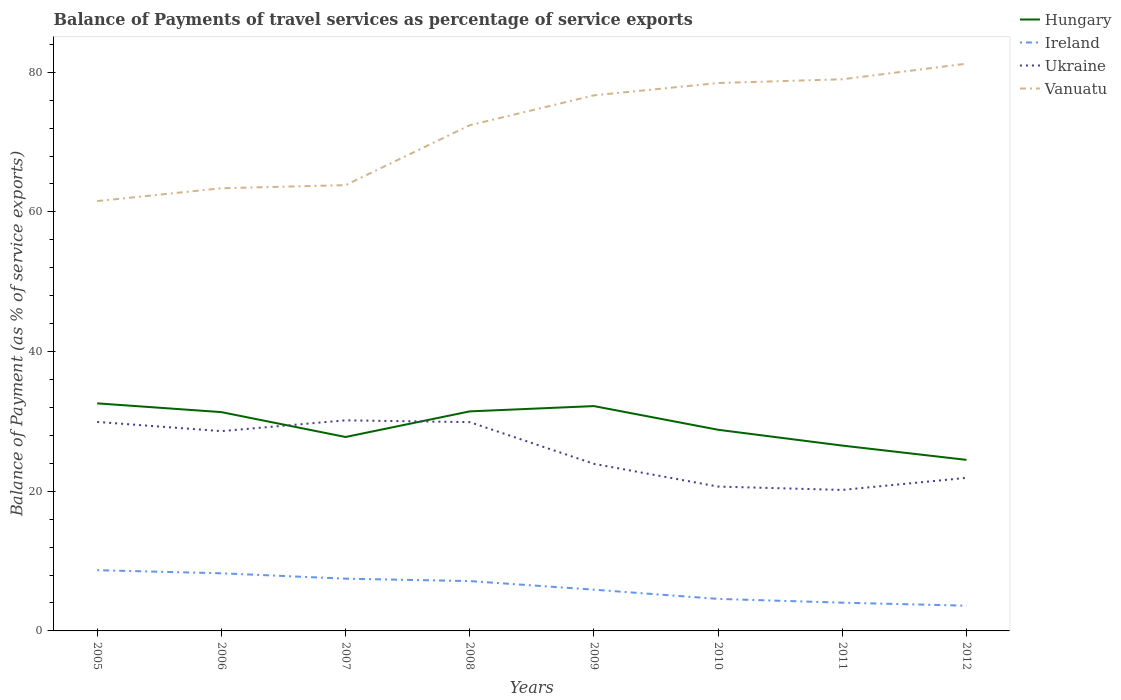Does the line corresponding to Vanuatu intersect with the line corresponding to Ireland?
Provide a short and direct response. No. Is the number of lines equal to the number of legend labels?
Your answer should be compact. Yes. Across all years, what is the maximum balance of payments of travel services in Ireland?
Offer a terse response. 3.61. What is the total balance of payments of travel services in Ukraine in the graph?
Give a very brief answer. 6. What is the difference between the highest and the second highest balance of payments of travel services in Ukraine?
Offer a very short reply. 9.97. What is the difference between the highest and the lowest balance of payments of travel services in Hungary?
Provide a succinct answer. 4. Are the values on the major ticks of Y-axis written in scientific E-notation?
Your answer should be very brief. No. Does the graph contain any zero values?
Ensure brevity in your answer.  No. Does the graph contain grids?
Give a very brief answer. No. How many legend labels are there?
Your response must be concise. 4. What is the title of the graph?
Provide a succinct answer. Balance of Payments of travel services as percentage of service exports. What is the label or title of the X-axis?
Your answer should be very brief. Years. What is the label or title of the Y-axis?
Make the answer very short. Balance of Payment (as % of service exports). What is the Balance of Payment (as % of service exports) of Hungary in 2005?
Ensure brevity in your answer.  32.59. What is the Balance of Payment (as % of service exports) in Ireland in 2005?
Offer a terse response. 8.7. What is the Balance of Payment (as % of service exports) in Ukraine in 2005?
Provide a succinct answer. 29.93. What is the Balance of Payment (as % of service exports) in Vanuatu in 2005?
Keep it short and to the point. 61.55. What is the Balance of Payment (as % of service exports) of Hungary in 2006?
Make the answer very short. 31.33. What is the Balance of Payment (as % of service exports) of Ireland in 2006?
Keep it short and to the point. 8.25. What is the Balance of Payment (as % of service exports) of Ukraine in 2006?
Provide a short and direct response. 28.61. What is the Balance of Payment (as % of service exports) of Vanuatu in 2006?
Your answer should be compact. 63.39. What is the Balance of Payment (as % of service exports) in Hungary in 2007?
Give a very brief answer. 27.77. What is the Balance of Payment (as % of service exports) in Ireland in 2007?
Provide a short and direct response. 7.48. What is the Balance of Payment (as % of service exports) in Ukraine in 2007?
Your response must be concise. 30.16. What is the Balance of Payment (as % of service exports) of Vanuatu in 2007?
Your answer should be very brief. 63.84. What is the Balance of Payment (as % of service exports) of Hungary in 2008?
Offer a terse response. 31.44. What is the Balance of Payment (as % of service exports) of Ireland in 2008?
Your answer should be very brief. 7.14. What is the Balance of Payment (as % of service exports) in Ukraine in 2008?
Provide a short and direct response. 29.9. What is the Balance of Payment (as % of service exports) in Vanuatu in 2008?
Give a very brief answer. 72.41. What is the Balance of Payment (as % of service exports) of Hungary in 2009?
Your answer should be very brief. 32.2. What is the Balance of Payment (as % of service exports) in Ireland in 2009?
Provide a succinct answer. 5.91. What is the Balance of Payment (as % of service exports) in Ukraine in 2009?
Provide a succinct answer. 23.93. What is the Balance of Payment (as % of service exports) in Vanuatu in 2009?
Ensure brevity in your answer.  76.69. What is the Balance of Payment (as % of service exports) of Hungary in 2010?
Your answer should be compact. 28.8. What is the Balance of Payment (as % of service exports) of Ireland in 2010?
Keep it short and to the point. 4.59. What is the Balance of Payment (as % of service exports) of Ukraine in 2010?
Keep it short and to the point. 20.67. What is the Balance of Payment (as % of service exports) in Vanuatu in 2010?
Provide a succinct answer. 78.46. What is the Balance of Payment (as % of service exports) in Hungary in 2011?
Offer a terse response. 26.54. What is the Balance of Payment (as % of service exports) of Ireland in 2011?
Ensure brevity in your answer.  4.04. What is the Balance of Payment (as % of service exports) of Ukraine in 2011?
Keep it short and to the point. 20.19. What is the Balance of Payment (as % of service exports) in Vanuatu in 2011?
Your response must be concise. 78.99. What is the Balance of Payment (as % of service exports) of Hungary in 2012?
Your answer should be compact. 24.5. What is the Balance of Payment (as % of service exports) of Ireland in 2012?
Keep it short and to the point. 3.61. What is the Balance of Payment (as % of service exports) in Ukraine in 2012?
Keep it short and to the point. 21.92. What is the Balance of Payment (as % of service exports) of Vanuatu in 2012?
Your answer should be very brief. 81.23. Across all years, what is the maximum Balance of Payment (as % of service exports) in Hungary?
Provide a short and direct response. 32.59. Across all years, what is the maximum Balance of Payment (as % of service exports) of Ireland?
Keep it short and to the point. 8.7. Across all years, what is the maximum Balance of Payment (as % of service exports) in Ukraine?
Make the answer very short. 30.16. Across all years, what is the maximum Balance of Payment (as % of service exports) of Vanuatu?
Provide a short and direct response. 81.23. Across all years, what is the minimum Balance of Payment (as % of service exports) in Hungary?
Provide a succinct answer. 24.5. Across all years, what is the minimum Balance of Payment (as % of service exports) of Ireland?
Provide a succinct answer. 3.61. Across all years, what is the minimum Balance of Payment (as % of service exports) of Ukraine?
Your answer should be very brief. 20.19. Across all years, what is the minimum Balance of Payment (as % of service exports) of Vanuatu?
Your answer should be compact. 61.55. What is the total Balance of Payment (as % of service exports) in Hungary in the graph?
Your answer should be compact. 235.16. What is the total Balance of Payment (as % of service exports) in Ireland in the graph?
Make the answer very short. 49.72. What is the total Balance of Payment (as % of service exports) in Ukraine in the graph?
Your answer should be very brief. 205.3. What is the total Balance of Payment (as % of service exports) of Vanuatu in the graph?
Your response must be concise. 576.56. What is the difference between the Balance of Payment (as % of service exports) of Hungary in 2005 and that in 2006?
Your answer should be very brief. 1.25. What is the difference between the Balance of Payment (as % of service exports) in Ireland in 2005 and that in 2006?
Offer a terse response. 0.45. What is the difference between the Balance of Payment (as % of service exports) of Ukraine in 2005 and that in 2006?
Your response must be concise. 1.32. What is the difference between the Balance of Payment (as % of service exports) in Vanuatu in 2005 and that in 2006?
Provide a succinct answer. -1.84. What is the difference between the Balance of Payment (as % of service exports) in Hungary in 2005 and that in 2007?
Your answer should be compact. 4.82. What is the difference between the Balance of Payment (as % of service exports) in Ireland in 2005 and that in 2007?
Your answer should be very brief. 1.22. What is the difference between the Balance of Payment (as % of service exports) in Ukraine in 2005 and that in 2007?
Offer a terse response. -0.23. What is the difference between the Balance of Payment (as % of service exports) in Vanuatu in 2005 and that in 2007?
Offer a terse response. -2.28. What is the difference between the Balance of Payment (as % of service exports) of Hungary in 2005 and that in 2008?
Your answer should be very brief. 1.15. What is the difference between the Balance of Payment (as % of service exports) of Ireland in 2005 and that in 2008?
Make the answer very short. 1.56. What is the difference between the Balance of Payment (as % of service exports) of Ukraine in 2005 and that in 2008?
Your response must be concise. 0.03. What is the difference between the Balance of Payment (as % of service exports) in Vanuatu in 2005 and that in 2008?
Make the answer very short. -10.86. What is the difference between the Balance of Payment (as % of service exports) in Hungary in 2005 and that in 2009?
Your response must be concise. 0.39. What is the difference between the Balance of Payment (as % of service exports) of Ireland in 2005 and that in 2009?
Make the answer very short. 2.79. What is the difference between the Balance of Payment (as % of service exports) of Ukraine in 2005 and that in 2009?
Your response must be concise. 6. What is the difference between the Balance of Payment (as % of service exports) of Vanuatu in 2005 and that in 2009?
Make the answer very short. -15.14. What is the difference between the Balance of Payment (as % of service exports) of Hungary in 2005 and that in 2010?
Offer a very short reply. 3.78. What is the difference between the Balance of Payment (as % of service exports) in Ireland in 2005 and that in 2010?
Provide a succinct answer. 4.11. What is the difference between the Balance of Payment (as % of service exports) of Ukraine in 2005 and that in 2010?
Your answer should be compact. 9.26. What is the difference between the Balance of Payment (as % of service exports) in Vanuatu in 2005 and that in 2010?
Provide a short and direct response. -16.9. What is the difference between the Balance of Payment (as % of service exports) in Hungary in 2005 and that in 2011?
Give a very brief answer. 6.05. What is the difference between the Balance of Payment (as % of service exports) in Ireland in 2005 and that in 2011?
Ensure brevity in your answer.  4.65. What is the difference between the Balance of Payment (as % of service exports) of Ukraine in 2005 and that in 2011?
Give a very brief answer. 9.74. What is the difference between the Balance of Payment (as % of service exports) of Vanuatu in 2005 and that in 2011?
Ensure brevity in your answer.  -17.44. What is the difference between the Balance of Payment (as % of service exports) of Hungary in 2005 and that in 2012?
Offer a very short reply. 8.09. What is the difference between the Balance of Payment (as % of service exports) of Ireland in 2005 and that in 2012?
Your answer should be compact. 5.09. What is the difference between the Balance of Payment (as % of service exports) in Ukraine in 2005 and that in 2012?
Offer a terse response. 8.01. What is the difference between the Balance of Payment (as % of service exports) of Vanuatu in 2005 and that in 2012?
Offer a terse response. -19.67. What is the difference between the Balance of Payment (as % of service exports) of Hungary in 2006 and that in 2007?
Give a very brief answer. 3.56. What is the difference between the Balance of Payment (as % of service exports) of Ireland in 2006 and that in 2007?
Provide a succinct answer. 0.77. What is the difference between the Balance of Payment (as % of service exports) in Ukraine in 2006 and that in 2007?
Keep it short and to the point. -1.55. What is the difference between the Balance of Payment (as % of service exports) of Vanuatu in 2006 and that in 2007?
Provide a short and direct response. -0.44. What is the difference between the Balance of Payment (as % of service exports) of Hungary in 2006 and that in 2008?
Keep it short and to the point. -0.1. What is the difference between the Balance of Payment (as % of service exports) in Ireland in 2006 and that in 2008?
Offer a terse response. 1.11. What is the difference between the Balance of Payment (as % of service exports) of Ukraine in 2006 and that in 2008?
Provide a short and direct response. -1.29. What is the difference between the Balance of Payment (as % of service exports) in Vanuatu in 2006 and that in 2008?
Your answer should be very brief. -9.02. What is the difference between the Balance of Payment (as % of service exports) of Hungary in 2006 and that in 2009?
Provide a short and direct response. -0.86. What is the difference between the Balance of Payment (as % of service exports) of Ireland in 2006 and that in 2009?
Offer a terse response. 2.34. What is the difference between the Balance of Payment (as % of service exports) of Ukraine in 2006 and that in 2009?
Offer a very short reply. 4.68. What is the difference between the Balance of Payment (as % of service exports) in Vanuatu in 2006 and that in 2009?
Your answer should be compact. -13.3. What is the difference between the Balance of Payment (as % of service exports) in Hungary in 2006 and that in 2010?
Make the answer very short. 2.53. What is the difference between the Balance of Payment (as % of service exports) of Ireland in 2006 and that in 2010?
Give a very brief answer. 3.67. What is the difference between the Balance of Payment (as % of service exports) in Ukraine in 2006 and that in 2010?
Give a very brief answer. 7.94. What is the difference between the Balance of Payment (as % of service exports) in Vanuatu in 2006 and that in 2010?
Your answer should be compact. -15.07. What is the difference between the Balance of Payment (as % of service exports) in Hungary in 2006 and that in 2011?
Provide a short and direct response. 4.79. What is the difference between the Balance of Payment (as % of service exports) of Ireland in 2006 and that in 2011?
Your answer should be compact. 4.21. What is the difference between the Balance of Payment (as % of service exports) of Ukraine in 2006 and that in 2011?
Offer a terse response. 8.42. What is the difference between the Balance of Payment (as % of service exports) in Vanuatu in 2006 and that in 2011?
Offer a terse response. -15.6. What is the difference between the Balance of Payment (as % of service exports) in Hungary in 2006 and that in 2012?
Provide a succinct answer. 6.84. What is the difference between the Balance of Payment (as % of service exports) in Ireland in 2006 and that in 2012?
Make the answer very short. 4.64. What is the difference between the Balance of Payment (as % of service exports) in Ukraine in 2006 and that in 2012?
Your answer should be very brief. 6.69. What is the difference between the Balance of Payment (as % of service exports) of Vanuatu in 2006 and that in 2012?
Ensure brevity in your answer.  -17.84. What is the difference between the Balance of Payment (as % of service exports) in Hungary in 2007 and that in 2008?
Offer a very short reply. -3.67. What is the difference between the Balance of Payment (as % of service exports) of Ireland in 2007 and that in 2008?
Offer a terse response. 0.35. What is the difference between the Balance of Payment (as % of service exports) in Ukraine in 2007 and that in 2008?
Make the answer very short. 0.26. What is the difference between the Balance of Payment (as % of service exports) of Vanuatu in 2007 and that in 2008?
Provide a short and direct response. -8.58. What is the difference between the Balance of Payment (as % of service exports) of Hungary in 2007 and that in 2009?
Keep it short and to the point. -4.43. What is the difference between the Balance of Payment (as % of service exports) in Ireland in 2007 and that in 2009?
Offer a terse response. 1.57. What is the difference between the Balance of Payment (as % of service exports) of Ukraine in 2007 and that in 2009?
Your response must be concise. 6.23. What is the difference between the Balance of Payment (as % of service exports) of Vanuatu in 2007 and that in 2009?
Ensure brevity in your answer.  -12.86. What is the difference between the Balance of Payment (as % of service exports) of Hungary in 2007 and that in 2010?
Offer a very short reply. -1.03. What is the difference between the Balance of Payment (as % of service exports) in Ireland in 2007 and that in 2010?
Provide a succinct answer. 2.9. What is the difference between the Balance of Payment (as % of service exports) in Ukraine in 2007 and that in 2010?
Offer a very short reply. 9.49. What is the difference between the Balance of Payment (as % of service exports) in Vanuatu in 2007 and that in 2010?
Keep it short and to the point. -14.62. What is the difference between the Balance of Payment (as % of service exports) of Hungary in 2007 and that in 2011?
Offer a very short reply. 1.23. What is the difference between the Balance of Payment (as % of service exports) in Ireland in 2007 and that in 2011?
Provide a succinct answer. 3.44. What is the difference between the Balance of Payment (as % of service exports) of Ukraine in 2007 and that in 2011?
Provide a short and direct response. 9.97. What is the difference between the Balance of Payment (as % of service exports) in Vanuatu in 2007 and that in 2011?
Your answer should be very brief. -15.16. What is the difference between the Balance of Payment (as % of service exports) in Hungary in 2007 and that in 2012?
Make the answer very short. 3.27. What is the difference between the Balance of Payment (as % of service exports) of Ireland in 2007 and that in 2012?
Provide a short and direct response. 3.87. What is the difference between the Balance of Payment (as % of service exports) in Ukraine in 2007 and that in 2012?
Keep it short and to the point. 8.24. What is the difference between the Balance of Payment (as % of service exports) in Vanuatu in 2007 and that in 2012?
Provide a short and direct response. -17.39. What is the difference between the Balance of Payment (as % of service exports) in Hungary in 2008 and that in 2009?
Offer a very short reply. -0.76. What is the difference between the Balance of Payment (as % of service exports) of Ireland in 2008 and that in 2009?
Provide a short and direct response. 1.23. What is the difference between the Balance of Payment (as % of service exports) of Ukraine in 2008 and that in 2009?
Ensure brevity in your answer.  5.97. What is the difference between the Balance of Payment (as % of service exports) in Vanuatu in 2008 and that in 2009?
Provide a succinct answer. -4.28. What is the difference between the Balance of Payment (as % of service exports) in Hungary in 2008 and that in 2010?
Your answer should be compact. 2.63. What is the difference between the Balance of Payment (as % of service exports) of Ireland in 2008 and that in 2010?
Provide a succinct answer. 2.55. What is the difference between the Balance of Payment (as % of service exports) of Ukraine in 2008 and that in 2010?
Your response must be concise. 9.23. What is the difference between the Balance of Payment (as % of service exports) in Vanuatu in 2008 and that in 2010?
Provide a short and direct response. -6.04. What is the difference between the Balance of Payment (as % of service exports) in Hungary in 2008 and that in 2011?
Your response must be concise. 4.9. What is the difference between the Balance of Payment (as % of service exports) in Ireland in 2008 and that in 2011?
Provide a short and direct response. 3.09. What is the difference between the Balance of Payment (as % of service exports) in Ukraine in 2008 and that in 2011?
Offer a very short reply. 9.71. What is the difference between the Balance of Payment (as % of service exports) of Vanuatu in 2008 and that in 2011?
Provide a succinct answer. -6.58. What is the difference between the Balance of Payment (as % of service exports) in Hungary in 2008 and that in 2012?
Offer a very short reply. 6.94. What is the difference between the Balance of Payment (as % of service exports) of Ireland in 2008 and that in 2012?
Offer a very short reply. 3.52. What is the difference between the Balance of Payment (as % of service exports) of Ukraine in 2008 and that in 2012?
Provide a short and direct response. 7.98. What is the difference between the Balance of Payment (as % of service exports) in Vanuatu in 2008 and that in 2012?
Give a very brief answer. -8.82. What is the difference between the Balance of Payment (as % of service exports) in Hungary in 2009 and that in 2010?
Give a very brief answer. 3.39. What is the difference between the Balance of Payment (as % of service exports) of Ireland in 2009 and that in 2010?
Provide a succinct answer. 1.32. What is the difference between the Balance of Payment (as % of service exports) in Ukraine in 2009 and that in 2010?
Your answer should be very brief. 3.26. What is the difference between the Balance of Payment (as % of service exports) of Vanuatu in 2009 and that in 2010?
Make the answer very short. -1.77. What is the difference between the Balance of Payment (as % of service exports) of Hungary in 2009 and that in 2011?
Your answer should be very brief. 5.65. What is the difference between the Balance of Payment (as % of service exports) of Ireland in 2009 and that in 2011?
Offer a terse response. 1.86. What is the difference between the Balance of Payment (as % of service exports) in Ukraine in 2009 and that in 2011?
Offer a very short reply. 3.74. What is the difference between the Balance of Payment (as % of service exports) in Vanuatu in 2009 and that in 2011?
Your answer should be very brief. -2.3. What is the difference between the Balance of Payment (as % of service exports) of Ireland in 2009 and that in 2012?
Your response must be concise. 2.3. What is the difference between the Balance of Payment (as % of service exports) in Ukraine in 2009 and that in 2012?
Your answer should be compact. 2.01. What is the difference between the Balance of Payment (as % of service exports) of Vanuatu in 2009 and that in 2012?
Your response must be concise. -4.54. What is the difference between the Balance of Payment (as % of service exports) of Hungary in 2010 and that in 2011?
Your response must be concise. 2.26. What is the difference between the Balance of Payment (as % of service exports) of Ireland in 2010 and that in 2011?
Your answer should be very brief. 0.54. What is the difference between the Balance of Payment (as % of service exports) of Ukraine in 2010 and that in 2011?
Offer a very short reply. 0.48. What is the difference between the Balance of Payment (as % of service exports) of Vanuatu in 2010 and that in 2011?
Your response must be concise. -0.54. What is the difference between the Balance of Payment (as % of service exports) in Hungary in 2010 and that in 2012?
Ensure brevity in your answer.  4.31. What is the difference between the Balance of Payment (as % of service exports) in Ireland in 2010 and that in 2012?
Provide a short and direct response. 0.97. What is the difference between the Balance of Payment (as % of service exports) in Ukraine in 2010 and that in 2012?
Your response must be concise. -1.25. What is the difference between the Balance of Payment (as % of service exports) of Vanuatu in 2010 and that in 2012?
Give a very brief answer. -2.77. What is the difference between the Balance of Payment (as % of service exports) in Hungary in 2011 and that in 2012?
Offer a very short reply. 2.05. What is the difference between the Balance of Payment (as % of service exports) in Ireland in 2011 and that in 2012?
Your response must be concise. 0.43. What is the difference between the Balance of Payment (as % of service exports) in Ukraine in 2011 and that in 2012?
Ensure brevity in your answer.  -1.73. What is the difference between the Balance of Payment (as % of service exports) in Vanuatu in 2011 and that in 2012?
Offer a very short reply. -2.23. What is the difference between the Balance of Payment (as % of service exports) of Hungary in 2005 and the Balance of Payment (as % of service exports) of Ireland in 2006?
Ensure brevity in your answer.  24.33. What is the difference between the Balance of Payment (as % of service exports) of Hungary in 2005 and the Balance of Payment (as % of service exports) of Ukraine in 2006?
Offer a terse response. 3.98. What is the difference between the Balance of Payment (as % of service exports) in Hungary in 2005 and the Balance of Payment (as % of service exports) in Vanuatu in 2006?
Give a very brief answer. -30.8. What is the difference between the Balance of Payment (as % of service exports) in Ireland in 2005 and the Balance of Payment (as % of service exports) in Ukraine in 2006?
Ensure brevity in your answer.  -19.91. What is the difference between the Balance of Payment (as % of service exports) of Ireland in 2005 and the Balance of Payment (as % of service exports) of Vanuatu in 2006?
Your response must be concise. -54.69. What is the difference between the Balance of Payment (as % of service exports) of Ukraine in 2005 and the Balance of Payment (as % of service exports) of Vanuatu in 2006?
Offer a very short reply. -33.46. What is the difference between the Balance of Payment (as % of service exports) of Hungary in 2005 and the Balance of Payment (as % of service exports) of Ireland in 2007?
Keep it short and to the point. 25.1. What is the difference between the Balance of Payment (as % of service exports) of Hungary in 2005 and the Balance of Payment (as % of service exports) of Ukraine in 2007?
Keep it short and to the point. 2.43. What is the difference between the Balance of Payment (as % of service exports) of Hungary in 2005 and the Balance of Payment (as % of service exports) of Vanuatu in 2007?
Keep it short and to the point. -31.25. What is the difference between the Balance of Payment (as % of service exports) of Ireland in 2005 and the Balance of Payment (as % of service exports) of Ukraine in 2007?
Your answer should be compact. -21.46. What is the difference between the Balance of Payment (as % of service exports) of Ireland in 2005 and the Balance of Payment (as % of service exports) of Vanuatu in 2007?
Provide a succinct answer. -55.14. What is the difference between the Balance of Payment (as % of service exports) of Ukraine in 2005 and the Balance of Payment (as % of service exports) of Vanuatu in 2007?
Give a very brief answer. -33.91. What is the difference between the Balance of Payment (as % of service exports) in Hungary in 2005 and the Balance of Payment (as % of service exports) in Ireland in 2008?
Your response must be concise. 25.45. What is the difference between the Balance of Payment (as % of service exports) in Hungary in 2005 and the Balance of Payment (as % of service exports) in Ukraine in 2008?
Your answer should be very brief. 2.69. What is the difference between the Balance of Payment (as % of service exports) in Hungary in 2005 and the Balance of Payment (as % of service exports) in Vanuatu in 2008?
Provide a short and direct response. -39.83. What is the difference between the Balance of Payment (as % of service exports) of Ireland in 2005 and the Balance of Payment (as % of service exports) of Ukraine in 2008?
Make the answer very short. -21.2. What is the difference between the Balance of Payment (as % of service exports) in Ireland in 2005 and the Balance of Payment (as % of service exports) in Vanuatu in 2008?
Your answer should be very brief. -63.71. What is the difference between the Balance of Payment (as % of service exports) in Ukraine in 2005 and the Balance of Payment (as % of service exports) in Vanuatu in 2008?
Keep it short and to the point. -42.49. What is the difference between the Balance of Payment (as % of service exports) of Hungary in 2005 and the Balance of Payment (as % of service exports) of Ireland in 2009?
Offer a very short reply. 26.68. What is the difference between the Balance of Payment (as % of service exports) of Hungary in 2005 and the Balance of Payment (as % of service exports) of Ukraine in 2009?
Offer a terse response. 8.66. What is the difference between the Balance of Payment (as % of service exports) of Hungary in 2005 and the Balance of Payment (as % of service exports) of Vanuatu in 2009?
Provide a succinct answer. -44.1. What is the difference between the Balance of Payment (as % of service exports) in Ireland in 2005 and the Balance of Payment (as % of service exports) in Ukraine in 2009?
Give a very brief answer. -15.23. What is the difference between the Balance of Payment (as % of service exports) of Ireland in 2005 and the Balance of Payment (as % of service exports) of Vanuatu in 2009?
Keep it short and to the point. -67.99. What is the difference between the Balance of Payment (as % of service exports) of Ukraine in 2005 and the Balance of Payment (as % of service exports) of Vanuatu in 2009?
Your answer should be compact. -46.76. What is the difference between the Balance of Payment (as % of service exports) of Hungary in 2005 and the Balance of Payment (as % of service exports) of Ireland in 2010?
Offer a very short reply. 28. What is the difference between the Balance of Payment (as % of service exports) of Hungary in 2005 and the Balance of Payment (as % of service exports) of Ukraine in 2010?
Make the answer very short. 11.92. What is the difference between the Balance of Payment (as % of service exports) in Hungary in 2005 and the Balance of Payment (as % of service exports) in Vanuatu in 2010?
Offer a terse response. -45.87. What is the difference between the Balance of Payment (as % of service exports) of Ireland in 2005 and the Balance of Payment (as % of service exports) of Ukraine in 2010?
Provide a short and direct response. -11.97. What is the difference between the Balance of Payment (as % of service exports) of Ireland in 2005 and the Balance of Payment (as % of service exports) of Vanuatu in 2010?
Make the answer very short. -69.76. What is the difference between the Balance of Payment (as % of service exports) of Ukraine in 2005 and the Balance of Payment (as % of service exports) of Vanuatu in 2010?
Offer a terse response. -48.53. What is the difference between the Balance of Payment (as % of service exports) of Hungary in 2005 and the Balance of Payment (as % of service exports) of Ireland in 2011?
Provide a succinct answer. 28.54. What is the difference between the Balance of Payment (as % of service exports) in Hungary in 2005 and the Balance of Payment (as % of service exports) in Ukraine in 2011?
Your answer should be compact. 12.4. What is the difference between the Balance of Payment (as % of service exports) of Hungary in 2005 and the Balance of Payment (as % of service exports) of Vanuatu in 2011?
Offer a terse response. -46.41. What is the difference between the Balance of Payment (as % of service exports) of Ireland in 2005 and the Balance of Payment (as % of service exports) of Ukraine in 2011?
Your answer should be very brief. -11.49. What is the difference between the Balance of Payment (as % of service exports) in Ireland in 2005 and the Balance of Payment (as % of service exports) in Vanuatu in 2011?
Keep it short and to the point. -70.3. What is the difference between the Balance of Payment (as % of service exports) in Ukraine in 2005 and the Balance of Payment (as % of service exports) in Vanuatu in 2011?
Your answer should be compact. -49.07. What is the difference between the Balance of Payment (as % of service exports) of Hungary in 2005 and the Balance of Payment (as % of service exports) of Ireland in 2012?
Provide a succinct answer. 28.97. What is the difference between the Balance of Payment (as % of service exports) of Hungary in 2005 and the Balance of Payment (as % of service exports) of Ukraine in 2012?
Ensure brevity in your answer.  10.67. What is the difference between the Balance of Payment (as % of service exports) of Hungary in 2005 and the Balance of Payment (as % of service exports) of Vanuatu in 2012?
Provide a short and direct response. -48.64. What is the difference between the Balance of Payment (as % of service exports) of Ireland in 2005 and the Balance of Payment (as % of service exports) of Ukraine in 2012?
Give a very brief answer. -13.22. What is the difference between the Balance of Payment (as % of service exports) in Ireland in 2005 and the Balance of Payment (as % of service exports) in Vanuatu in 2012?
Provide a short and direct response. -72.53. What is the difference between the Balance of Payment (as % of service exports) in Ukraine in 2005 and the Balance of Payment (as % of service exports) in Vanuatu in 2012?
Provide a succinct answer. -51.3. What is the difference between the Balance of Payment (as % of service exports) in Hungary in 2006 and the Balance of Payment (as % of service exports) in Ireland in 2007?
Your answer should be very brief. 23.85. What is the difference between the Balance of Payment (as % of service exports) in Hungary in 2006 and the Balance of Payment (as % of service exports) in Ukraine in 2007?
Give a very brief answer. 1.18. What is the difference between the Balance of Payment (as % of service exports) in Hungary in 2006 and the Balance of Payment (as % of service exports) in Vanuatu in 2007?
Your response must be concise. -32.5. What is the difference between the Balance of Payment (as % of service exports) of Ireland in 2006 and the Balance of Payment (as % of service exports) of Ukraine in 2007?
Your response must be concise. -21.9. What is the difference between the Balance of Payment (as % of service exports) of Ireland in 2006 and the Balance of Payment (as % of service exports) of Vanuatu in 2007?
Keep it short and to the point. -55.58. What is the difference between the Balance of Payment (as % of service exports) of Ukraine in 2006 and the Balance of Payment (as % of service exports) of Vanuatu in 2007?
Provide a short and direct response. -35.23. What is the difference between the Balance of Payment (as % of service exports) of Hungary in 2006 and the Balance of Payment (as % of service exports) of Ireland in 2008?
Keep it short and to the point. 24.2. What is the difference between the Balance of Payment (as % of service exports) in Hungary in 2006 and the Balance of Payment (as % of service exports) in Ukraine in 2008?
Your answer should be very brief. 1.43. What is the difference between the Balance of Payment (as % of service exports) of Hungary in 2006 and the Balance of Payment (as % of service exports) of Vanuatu in 2008?
Provide a succinct answer. -41.08. What is the difference between the Balance of Payment (as % of service exports) in Ireland in 2006 and the Balance of Payment (as % of service exports) in Ukraine in 2008?
Give a very brief answer. -21.65. What is the difference between the Balance of Payment (as % of service exports) in Ireland in 2006 and the Balance of Payment (as % of service exports) in Vanuatu in 2008?
Provide a short and direct response. -64.16. What is the difference between the Balance of Payment (as % of service exports) in Ukraine in 2006 and the Balance of Payment (as % of service exports) in Vanuatu in 2008?
Provide a succinct answer. -43.8. What is the difference between the Balance of Payment (as % of service exports) of Hungary in 2006 and the Balance of Payment (as % of service exports) of Ireland in 2009?
Ensure brevity in your answer.  25.42. What is the difference between the Balance of Payment (as % of service exports) in Hungary in 2006 and the Balance of Payment (as % of service exports) in Ukraine in 2009?
Give a very brief answer. 7.41. What is the difference between the Balance of Payment (as % of service exports) in Hungary in 2006 and the Balance of Payment (as % of service exports) in Vanuatu in 2009?
Give a very brief answer. -45.36. What is the difference between the Balance of Payment (as % of service exports) of Ireland in 2006 and the Balance of Payment (as % of service exports) of Ukraine in 2009?
Provide a short and direct response. -15.67. What is the difference between the Balance of Payment (as % of service exports) in Ireland in 2006 and the Balance of Payment (as % of service exports) in Vanuatu in 2009?
Provide a short and direct response. -68.44. What is the difference between the Balance of Payment (as % of service exports) in Ukraine in 2006 and the Balance of Payment (as % of service exports) in Vanuatu in 2009?
Keep it short and to the point. -48.08. What is the difference between the Balance of Payment (as % of service exports) in Hungary in 2006 and the Balance of Payment (as % of service exports) in Ireland in 2010?
Keep it short and to the point. 26.75. What is the difference between the Balance of Payment (as % of service exports) in Hungary in 2006 and the Balance of Payment (as % of service exports) in Ukraine in 2010?
Make the answer very short. 10.66. What is the difference between the Balance of Payment (as % of service exports) in Hungary in 2006 and the Balance of Payment (as % of service exports) in Vanuatu in 2010?
Offer a terse response. -47.12. What is the difference between the Balance of Payment (as % of service exports) of Ireland in 2006 and the Balance of Payment (as % of service exports) of Ukraine in 2010?
Offer a terse response. -12.42. What is the difference between the Balance of Payment (as % of service exports) in Ireland in 2006 and the Balance of Payment (as % of service exports) in Vanuatu in 2010?
Offer a terse response. -70.21. What is the difference between the Balance of Payment (as % of service exports) of Ukraine in 2006 and the Balance of Payment (as % of service exports) of Vanuatu in 2010?
Ensure brevity in your answer.  -49.85. What is the difference between the Balance of Payment (as % of service exports) in Hungary in 2006 and the Balance of Payment (as % of service exports) in Ireland in 2011?
Your answer should be compact. 27.29. What is the difference between the Balance of Payment (as % of service exports) in Hungary in 2006 and the Balance of Payment (as % of service exports) in Ukraine in 2011?
Provide a succinct answer. 11.14. What is the difference between the Balance of Payment (as % of service exports) of Hungary in 2006 and the Balance of Payment (as % of service exports) of Vanuatu in 2011?
Ensure brevity in your answer.  -47.66. What is the difference between the Balance of Payment (as % of service exports) of Ireland in 2006 and the Balance of Payment (as % of service exports) of Ukraine in 2011?
Provide a succinct answer. -11.94. What is the difference between the Balance of Payment (as % of service exports) in Ireland in 2006 and the Balance of Payment (as % of service exports) in Vanuatu in 2011?
Provide a short and direct response. -70.74. What is the difference between the Balance of Payment (as % of service exports) of Ukraine in 2006 and the Balance of Payment (as % of service exports) of Vanuatu in 2011?
Offer a very short reply. -50.38. What is the difference between the Balance of Payment (as % of service exports) of Hungary in 2006 and the Balance of Payment (as % of service exports) of Ireland in 2012?
Your response must be concise. 27.72. What is the difference between the Balance of Payment (as % of service exports) of Hungary in 2006 and the Balance of Payment (as % of service exports) of Ukraine in 2012?
Your answer should be very brief. 9.41. What is the difference between the Balance of Payment (as % of service exports) in Hungary in 2006 and the Balance of Payment (as % of service exports) in Vanuatu in 2012?
Ensure brevity in your answer.  -49.9. What is the difference between the Balance of Payment (as % of service exports) of Ireland in 2006 and the Balance of Payment (as % of service exports) of Ukraine in 2012?
Provide a succinct answer. -13.67. What is the difference between the Balance of Payment (as % of service exports) of Ireland in 2006 and the Balance of Payment (as % of service exports) of Vanuatu in 2012?
Provide a succinct answer. -72.98. What is the difference between the Balance of Payment (as % of service exports) of Ukraine in 2006 and the Balance of Payment (as % of service exports) of Vanuatu in 2012?
Offer a terse response. -52.62. What is the difference between the Balance of Payment (as % of service exports) of Hungary in 2007 and the Balance of Payment (as % of service exports) of Ireland in 2008?
Your answer should be very brief. 20.63. What is the difference between the Balance of Payment (as % of service exports) of Hungary in 2007 and the Balance of Payment (as % of service exports) of Ukraine in 2008?
Provide a succinct answer. -2.13. What is the difference between the Balance of Payment (as % of service exports) in Hungary in 2007 and the Balance of Payment (as % of service exports) in Vanuatu in 2008?
Provide a succinct answer. -44.64. What is the difference between the Balance of Payment (as % of service exports) of Ireland in 2007 and the Balance of Payment (as % of service exports) of Ukraine in 2008?
Keep it short and to the point. -22.42. What is the difference between the Balance of Payment (as % of service exports) of Ireland in 2007 and the Balance of Payment (as % of service exports) of Vanuatu in 2008?
Your response must be concise. -64.93. What is the difference between the Balance of Payment (as % of service exports) of Ukraine in 2007 and the Balance of Payment (as % of service exports) of Vanuatu in 2008?
Offer a very short reply. -42.26. What is the difference between the Balance of Payment (as % of service exports) of Hungary in 2007 and the Balance of Payment (as % of service exports) of Ireland in 2009?
Your response must be concise. 21.86. What is the difference between the Balance of Payment (as % of service exports) in Hungary in 2007 and the Balance of Payment (as % of service exports) in Ukraine in 2009?
Keep it short and to the point. 3.84. What is the difference between the Balance of Payment (as % of service exports) of Hungary in 2007 and the Balance of Payment (as % of service exports) of Vanuatu in 2009?
Give a very brief answer. -48.92. What is the difference between the Balance of Payment (as % of service exports) in Ireland in 2007 and the Balance of Payment (as % of service exports) in Ukraine in 2009?
Make the answer very short. -16.44. What is the difference between the Balance of Payment (as % of service exports) of Ireland in 2007 and the Balance of Payment (as % of service exports) of Vanuatu in 2009?
Make the answer very short. -69.21. What is the difference between the Balance of Payment (as % of service exports) in Ukraine in 2007 and the Balance of Payment (as % of service exports) in Vanuatu in 2009?
Keep it short and to the point. -46.53. What is the difference between the Balance of Payment (as % of service exports) in Hungary in 2007 and the Balance of Payment (as % of service exports) in Ireland in 2010?
Make the answer very short. 23.18. What is the difference between the Balance of Payment (as % of service exports) of Hungary in 2007 and the Balance of Payment (as % of service exports) of Ukraine in 2010?
Your answer should be very brief. 7.1. What is the difference between the Balance of Payment (as % of service exports) of Hungary in 2007 and the Balance of Payment (as % of service exports) of Vanuatu in 2010?
Make the answer very short. -50.69. What is the difference between the Balance of Payment (as % of service exports) of Ireland in 2007 and the Balance of Payment (as % of service exports) of Ukraine in 2010?
Make the answer very short. -13.19. What is the difference between the Balance of Payment (as % of service exports) in Ireland in 2007 and the Balance of Payment (as % of service exports) in Vanuatu in 2010?
Offer a terse response. -70.97. What is the difference between the Balance of Payment (as % of service exports) in Ukraine in 2007 and the Balance of Payment (as % of service exports) in Vanuatu in 2010?
Keep it short and to the point. -48.3. What is the difference between the Balance of Payment (as % of service exports) in Hungary in 2007 and the Balance of Payment (as % of service exports) in Ireland in 2011?
Provide a succinct answer. 23.73. What is the difference between the Balance of Payment (as % of service exports) of Hungary in 2007 and the Balance of Payment (as % of service exports) of Ukraine in 2011?
Give a very brief answer. 7.58. What is the difference between the Balance of Payment (as % of service exports) in Hungary in 2007 and the Balance of Payment (as % of service exports) in Vanuatu in 2011?
Give a very brief answer. -51.23. What is the difference between the Balance of Payment (as % of service exports) in Ireland in 2007 and the Balance of Payment (as % of service exports) in Ukraine in 2011?
Provide a short and direct response. -12.71. What is the difference between the Balance of Payment (as % of service exports) of Ireland in 2007 and the Balance of Payment (as % of service exports) of Vanuatu in 2011?
Provide a short and direct response. -71.51. What is the difference between the Balance of Payment (as % of service exports) in Ukraine in 2007 and the Balance of Payment (as % of service exports) in Vanuatu in 2011?
Offer a very short reply. -48.84. What is the difference between the Balance of Payment (as % of service exports) of Hungary in 2007 and the Balance of Payment (as % of service exports) of Ireland in 2012?
Keep it short and to the point. 24.16. What is the difference between the Balance of Payment (as % of service exports) in Hungary in 2007 and the Balance of Payment (as % of service exports) in Ukraine in 2012?
Provide a succinct answer. 5.85. What is the difference between the Balance of Payment (as % of service exports) in Hungary in 2007 and the Balance of Payment (as % of service exports) in Vanuatu in 2012?
Your answer should be compact. -53.46. What is the difference between the Balance of Payment (as % of service exports) of Ireland in 2007 and the Balance of Payment (as % of service exports) of Ukraine in 2012?
Make the answer very short. -14.44. What is the difference between the Balance of Payment (as % of service exports) in Ireland in 2007 and the Balance of Payment (as % of service exports) in Vanuatu in 2012?
Your answer should be very brief. -73.75. What is the difference between the Balance of Payment (as % of service exports) in Ukraine in 2007 and the Balance of Payment (as % of service exports) in Vanuatu in 2012?
Offer a very short reply. -51.07. What is the difference between the Balance of Payment (as % of service exports) of Hungary in 2008 and the Balance of Payment (as % of service exports) of Ireland in 2009?
Your response must be concise. 25.53. What is the difference between the Balance of Payment (as % of service exports) of Hungary in 2008 and the Balance of Payment (as % of service exports) of Ukraine in 2009?
Give a very brief answer. 7.51. What is the difference between the Balance of Payment (as % of service exports) in Hungary in 2008 and the Balance of Payment (as % of service exports) in Vanuatu in 2009?
Your answer should be very brief. -45.25. What is the difference between the Balance of Payment (as % of service exports) in Ireland in 2008 and the Balance of Payment (as % of service exports) in Ukraine in 2009?
Give a very brief answer. -16.79. What is the difference between the Balance of Payment (as % of service exports) of Ireland in 2008 and the Balance of Payment (as % of service exports) of Vanuatu in 2009?
Provide a succinct answer. -69.55. What is the difference between the Balance of Payment (as % of service exports) of Ukraine in 2008 and the Balance of Payment (as % of service exports) of Vanuatu in 2009?
Ensure brevity in your answer.  -46.79. What is the difference between the Balance of Payment (as % of service exports) in Hungary in 2008 and the Balance of Payment (as % of service exports) in Ireland in 2010?
Offer a terse response. 26.85. What is the difference between the Balance of Payment (as % of service exports) of Hungary in 2008 and the Balance of Payment (as % of service exports) of Ukraine in 2010?
Offer a terse response. 10.77. What is the difference between the Balance of Payment (as % of service exports) in Hungary in 2008 and the Balance of Payment (as % of service exports) in Vanuatu in 2010?
Provide a short and direct response. -47.02. What is the difference between the Balance of Payment (as % of service exports) in Ireland in 2008 and the Balance of Payment (as % of service exports) in Ukraine in 2010?
Keep it short and to the point. -13.53. What is the difference between the Balance of Payment (as % of service exports) in Ireland in 2008 and the Balance of Payment (as % of service exports) in Vanuatu in 2010?
Your answer should be very brief. -71.32. What is the difference between the Balance of Payment (as % of service exports) of Ukraine in 2008 and the Balance of Payment (as % of service exports) of Vanuatu in 2010?
Offer a very short reply. -48.56. What is the difference between the Balance of Payment (as % of service exports) in Hungary in 2008 and the Balance of Payment (as % of service exports) in Ireland in 2011?
Keep it short and to the point. 27.39. What is the difference between the Balance of Payment (as % of service exports) of Hungary in 2008 and the Balance of Payment (as % of service exports) of Ukraine in 2011?
Give a very brief answer. 11.25. What is the difference between the Balance of Payment (as % of service exports) in Hungary in 2008 and the Balance of Payment (as % of service exports) in Vanuatu in 2011?
Provide a short and direct response. -47.56. What is the difference between the Balance of Payment (as % of service exports) in Ireland in 2008 and the Balance of Payment (as % of service exports) in Ukraine in 2011?
Your answer should be compact. -13.05. What is the difference between the Balance of Payment (as % of service exports) of Ireland in 2008 and the Balance of Payment (as % of service exports) of Vanuatu in 2011?
Your answer should be compact. -71.86. What is the difference between the Balance of Payment (as % of service exports) of Ukraine in 2008 and the Balance of Payment (as % of service exports) of Vanuatu in 2011?
Provide a short and direct response. -49.1. What is the difference between the Balance of Payment (as % of service exports) in Hungary in 2008 and the Balance of Payment (as % of service exports) in Ireland in 2012?
Your answer should be very brief. 27.83. What is the difference between the Balance of Payment (as % of service exports) of Hungary in 2008 and the Balance of Payment (as % of service exports) of Ukraine in 2012?
Offer a terse response. 9.52. What is the difference between the Balance of Payment (as % of service exports) of Hungary in 2008 and the Balance of Payment (as % of service exports) of Vanuatu in 2012?
Give a very brief answer. -49.79. What is the difference between the Balance of Payment (as % of service exports) in Ireland in 2008 and the Balance of Payment (as % of service exports) in Ukraine in 2012?
Provide a short and direct response. -14.78. What is the difference between the Balance of Payment (as % of service exports) of Ireland in 2008 and the Balance of Payment (as % of service exports) of Vanuatu in 2012?
Offer a terse response. -74.09. What is the difference between the Balance of Payment (as % of service exports) of Ukraine in 2008 and the Balance of Payment (as % of service exports) of Vanuatu in 2012?
Offer a terse response. -51.33. What is the difference between the Balance of Payment (as % of service exports) in Hungary in 2009 and the Balance of Payment (as % of service exports) in Ireland in 2010?
Offer a very short reply. 27.61. What is the difference between the Balance of Payment (as % of service exports) in Hungary in 2009 and the Balance of Payment (as % of service exports) in Ukraine in 2010?
Your answer should be very brief. 11.53. What is the difference between the Balance of Payment (as % of service exports) in Hungary in 2009 and the Balance of Payment (as % of service exports) in Vanuatu in 2010?
Ensure brevity in your answer.  -46.26. What is the difference between the Balance of Payment (as % of service exports) in Ireland in 2009 and the Balance of Payment (as % of service exports) in Ukraine in 2010?
Your answer should be compact. -14.76. What is the difference between the Balance of Payment (as % of service exports) in Ireland in 2009 and the Balance of Payment (as % of service exports) in Vanuatu in 2010?
Offer a very short reply. -72.55. What is the difference between the Balance of Payment (as % of service exports) of Ukraine in 2009 and the Balance of Payment (as % of service exports) of Vanuatu in 2010?
Provide a succinct answer. -54.53. What is the difference between the Balance of Payment (as % of service exports) in Hungary in 2009 and the Balance of Payment (as % of service exports) in Ireland in 2011?
Offer a very short reply. 28.15. What is the difference between the Balance of Payment (as % of service exports) of Hungary in 2009 and the Balance of Payment (as % of service exports) of Ukraine in 2011?
Your response must be concise. 12.01. What is the difference between the Balance of Payment (as % of service exports) in Hungary in 2009 and the Balance of Payment (as % of service exports) in Vanuatu in 2011?
Offer a very short reply. -46.8. What is the difference between the Balance of Payment (as % of service exports) of Ireland in 2009 and the Balance of Payment (as % of service exports) of Ukraine in 2011?
Offer a terse response. -14.28. What is the difference between the Balance of Payment (as % of service exports) of Ireland in 2009 and the Balance of Payment (as % of service exports) of Vanuatu in 2011?
Ensure brevity in your answer.  -73.09. What is the difference between the Balance of Payment (as % of service exports) in Ukraine in 2009 and the Balance of Payment (as % of service exports) in Vanuatu in 2011?
Your response must be concise. -55.07. What is the difference between the Balance of Payment (as % of service exports) of Hungary in 2009 and the Balance of Payment (as % of service exports) of Ireland in 2012?
Give a very brief answer. 28.58. What is the difference between the Balance of Payment (as % of service exports) of Hungary in 2009 and the Balance of Payment (as % of service exports) of Ukraine in 2012?
Give a very brief answer. 10.27. What is the difference between the Balance of Payment (as % of service exports) in Hungary in 2009 and the Balance of Payment (as % of service exports) in Vanuatu in 2012?
Keep it short and to the point. -49.03. What is the difference between the Balance of Payment (as % of service exports) of Ireland in 2009 and the Balance of Payment (as % of service exports) of Ukraine in 2012?
Ensure brevity in your answer.  -16.01. What is the difference between the Balance of Payment (as % of service exports) in Ireland in 2009 and the Balance of Payment (as % of service exports) in Vanuatu in 2012?
Your answer should be compact. -75.32. What is the difference between the Balance of Payment (as % of service exports) of Ukraine in 2009 and the Balance of Payment (as % of service exports) of Vanuatu in 2012?
Give a very brief answer. -57.3. What is the difference between the Balance of Payment (as % of service exports) in Hungary in 2010 and the Balance of Payment (as % of service exports) in Ireland in 2011?
Give a very brief answer. 24.76. What is the difference between the Balance of Payment (as % of service exports) in Hungary in 2010 and the Balance of Payment (as % of service exports) in Ukraine in 2011?
Give a very brief answer. 8.62. What is the difference between the Balance of Payment (as % of service exports) in Hungary in 2010 and the Balance of Payment (as % of service exports) in Vanuatu in 2011?
Make the answer very short. -50.19. What is the difference between the Balance of Payment (as % of service exports) in Ireland in 2010 and the Balance of Payment (as % of service exports) in Ukraine in 2011?
Make the answer very short. -15.6. What is the difference between the Balance of Payment (as % of service exports) of Ireland in 2010 and the Balance of Payment (as % of service exports) of Vanuatu in 2011?
Your answer should be compact. -74.41. What is the difference between the Balance of Payment (as % of service exports) in Ukraine in 2010 and the Balance of Payment (as % of service exports) in Vanuatu in 2011?
Your answer should be very brief. -58.33. What is the difference between the Balance of Payment (as % of service exports) in Hungary in 2010 and the Balance of Payment (as % of service exports) in Ireland in 2012?
Your answer should be very brief. 25.19. What is the difference between the Balance of Payment (as % of service exports) in Hungary in 2010 and the Balance of Payment (as % of service exports) in Ukraine in 2012?
Make the answer very short. 6.88. What is the difference between the Balance of Payment (as % of service exports) in Hungary in 2010 and the Balance of Payment (as % of service exports) in Vanuatu in 2012?
Your answer should be compact. -52.42. What is the difference between the Balance of Payment (as % of service exports) of Ireland in 2010 and the Balance of Payment (as % of service exports) of Ukraine in 2012?
Your response must be concise. -17.33. What is the difference between the Balance of Payment (as % of service exports) in Ireland in 2010 and the Balance of Payment (as % of service exports) in Vanuatu in 2012?
Offer a terse response. -76.64. What is the difference between the Balance of Payment (as % of service exports) of Ukraine in 2010 and the Balance of Payment (as % of service exports) of Vanuatu in 2012?
Give a very brief answer. -60.56. What is the difference between the Balance of Payment (as % of service exports) of Hungary in 2011 and the Balance of Payment (as % of service exports) of Ireland in 2012?
Offer a terse response. 22.93. What is the difference between the Balance of Payment (as % of service exports) in Hungary in 2011 and the Balance of Payment (as % of service exports) in Ukraine in 2012?
Provide a short and direct response. 4.62. What is the difference between the Balance of Payment (as % of service exports) in Hungary in 2011 and the Balance of Payment (as % of service exports) in Vanuatu in 2012?
Your response must be concise. -54.69. What is the difference between the Balance of Payment (as % of service exports) of Ireland in 2011 and the Balance of Payment (as % of service exports) of Ukraine in 2012?
Provide a short and direct response. -17.88. What is the difference between the Balance of Payment (as % of service exports) of Ireland in 2011 and the Balance of Payment (as % of service exports) of Vanuatu in 2012?
Give a very brief answer. -77.18. What is the difference between the Balance of Payment (as % of service exports) in Ukraine in 2011 and the Balance of Payment (as % of service exports) in Vanuatu in 2012?
Offer a terse response. -61.04. What is the average Balance of Payment (as % of service exports) of Hungary per year?
Your answer should be compact. 29.4. What is the average Balance of Payment (as % of service exports) in Ireland per year?
Give a very brief answer. 6.21. What is the average Balance of Payment (as % of service exports) of Ukraine per year?
Your answer should be compact. 25.66. What is the average Balance of Payment (as % of service exports) of Vanuatu per year?
Your answer should be very brief. 72.07. In the year 2005, what is the difference between the Balance of Payment (as % of service exports) of Hungary and Balance of Payment (as % of service exports) of Ireland?
Keep it short and to the point. 23.89. In the year 2005, what is the difference between the Balance of Payment (as % of service exports) of Hungary and Balance of Payment (as % of service exports) of Ukraine?
Your response must be concise. 2.66. In the year 2005, what is the difference between the Balance of Payment (as % of service exports) of Hungary and Balance of Payment (as % of service exports) of Vanuatu?
Provide a short and direct response. -28.97. In the year 2005, what is the difference between the Balance of Payment (as % of service exports) of Ireland and Balance of Payment (as % of service exports) of Ukraine?
Offer a very short reply. -21.23. In the year 2005, what is the difference between the Balance of Payment (as % of service exports) of Ireland and Balance of Payment (as % of service exports) of Vanuatu?
Your response must be concise. -52.86. In the year 2005, what is the difference between the Balance of Payment (as % of service exports) in Ukraine and Balance of Payment (as % of service exports) in Vanuatu?
Offer a very short reply. -31.63. In the year 2006, what is the difference between the Balance of Payment (as % of service exports) in Hungary and Balance of Payment (as % of service exports) in Ireland?
Provide a succinct answer. 23.08. In the year 2006, what is the difference between the Balance of Payment (as % of service exports) in Hungary and Balance of Payment (as % of service exports) in Ukraine?
Offer a very short reply. 2.72. In the year 2006, what is the difference between the Balance of Payment (as % of service exports) of Hungary and Balance of Payment (as % of service exports) of Vanuatu?
Keep it short and to the point. -32.06. In the year 2006, what is the difference between the Balance of Payment (as % of service exports) in Ireland and Balance of Payment (as % of service exports) in Ukraine?
Give a very brief answer. -20.36. In the year 2006, what is the difference between the Balance of Payment (as % of service exports) of Ireland and Balance of Payment (as % of service exports) of Vanuatu?
Provide a short and direct response. -55.14. In the year 2006, what is the difference between the Balance of Payment (as % of service exports) in Ukraine and Balance of Payment (as % of service exports) in Vanuatu?
Ensure brevity in your answer.  -34.78. In the year 2007, what is the difference between the Balance of Payment (as % of service exports) in Hungary and Balance of Payment (as % of service exports) in Ireland?
Offer a very short reply. 20.29. In the year 2007, what is the difference between the Balance of Payment (as % of service exports) in Hungary and Balance of Payment (as % of service exports) in Ukraine?
Provide a short and direct response. -2.39. In the year 2007, what is the difference between the Balance of Payment (as % of service exports) in Hungary and Balance of Payment (as % of service exports) in Vanuatu?
Your answer should be compact. -36.07. In the year 2007, what is the difference between the Balance of Payment (as % of service exports) in Ireland and Balance of Payment (as % of service exports) in Ukraine?
Your answer should be very brief. -22.67. In the year 2007, what is the difference between the Balance of Payment (as % of service exports) of Ireland and Balance of Payment (as % of service exports) of Vanuatu?
Your answer should be compact. -56.35. In the year 2007, what is the difference between the Balance of Payment (as % of service exports) in Ukraine and Balance of Payment (as % of service exports) in Vanuatu?
Keep it short and to the point. -33.68. In the year 2008, what is the difference between the Balance of Payment (as % of service exports) of Hungary and Balance of Payment (as % of service exports) of Ireland?
Your answer should be compact. 24.3. In the year 2008, what is the difference between the Balance of Payment (as % of service exports) of Hungary and Balance of Payment (as % of service exports) of Ukraine?
Ensure brevity in your answer.  1.54. In the year 2008, what is the difference between the Balance of Payment (as % of service exports) in Hungary and Balance of Payment (as % of service exports) in Vanuatu?
Give a very brief answer. -40.97. In the year 2008, what is the difference between the Balance of Payment (as % of service exports) in Ireland and Balance of Payment (as % of service exports) in Ukraine?
Keep it short and to the point. -22.76. In the year 2008, what is the difference between the Balance of Payment (as % of service exports) in Ireland and Balance of Payment (as % of service exports) in Vanuatu?
Keep it short and to the point. -65.28. In the year 2008, what is the difference between the Balance of Payment (as % of service exports) of Ukraine and Balance of Payment (as % of service exports) of Vanuatu?
Give a very brief answer. -42.51. In the year 2009, what is the difference between the Balance of Payment (as % of service exports) of Hungary and Balance of Payment (as % of service exports) of Ireland?
Make the answer very short. 26.29. In the year 2009, what is the difference between the Balance of Payment (as % of service exports) of Hungary and Balance of Payment (as % of service exports) of Ukraine?
Your answer should be very brief. 8.27. In the year 2009, what is the difference between the Balance of Payment (as % of service exports) of Hungary and Balance of Payment (as % of service exports) of Vanuatu?
Make the answer very short. -44.5. In the year 2009, what is the difference between the Balance of Payment (as % of service exports) in Ireland and Balance of Payment (as % of service exports) in Ukraine?
Provide a succinct answer. -18.02. In the year 2009, what is the difference between the Balance of Payment (as % of service exports) in Ireland and Balance of Payment (as % of service exports) in Vanuatu?
Ensure brevity in your answer.  -70.78. In the year 2009, what is the difference between the Balance of Payment (as % of service exports) of Ukraine and Balance of Payment (as % of service exports) of Vanuatu?
Keep it short and to the point. -52.76. In the year 2010, what is the difference between the Balance of Payment (as % of service exports) of Hungary and Balance of Payment (as % of service exports) of Ireland?
Offer a very short reply. 24.22. In the year 2010, what is the difference between the Balance of Payment (as % of service exports) of Hungary and Balance of Payment (as % of service exports) of Ukraine?
Give a very brief answer. 8.14. In the year 2010, what is the difference between the Balance of Payment (as % of service exports) in Hungary and Balance of Payment (as % of service exports) in Vanuatu?
Offer a terse response. -49.65. In the year 2010, what is the difference between the Balance of Payment (as % of service exports) of Ireland and Balance of Payment (as % of service exports) of Ukraine?
Provide a short and direct response. -16.08. In the year 2010, what is the difference between the Balance of Payment (as % of service exports) in Ireland and Balance of Payment (as % of service exports) in Vanuatu?
Offer a terse response. -73.87. In the year 2010, what is the difference between the Balance of Payment (as % of service exports) in Ukraine and Balance of Payment (as % of service exports) in Vanuatu?
Offer a very short reply. -57.79. In the year 2011, what is the difference between the Balance of Payment (as % of service exports) in Hungary and Balance of Payment (as % of service exports) in Ireland?
Ensure brevity in your answer.  22.5. In the year 2011, what is the difference between the Balance of Payment (as % of service exports) of Hungary and Balance of Payment (as % of service exports) of Ukraine?
Your answer should be very brief. 6.35. In the year 2011, what is the difference between the Balance of Payment (as % of service exports) of Hungary and Balance of Payment (as % of service exports) of Vanuatu?
Offer a very short reply. -52.45. In the year 2011, what is the difference between the Balance of Payment (as % of service exports) of Ireland and Balance of Payment (as % of service exports) of Ukraine?
Provide a short and direct response. -16.14. In the year 2011, what is the difference between the Balance of Payment (as % of service exports) of Ireland and Balance of Payment (as % of service exports) of Vanuatu?
Your answer should be compact. -74.95. In the year 2011, what is the difference between the Balance of Payment (as % of service exports) of Ukraine and Balance of Payment (as % of service exports) of Vanuatu?
Your answer should be very brief. -58.81. In the year 2012, what is the difference between the Balance of Payment (as % of service exports) in Hungary and Balance of Payment (as % of service exports) in Ireland?
Keep it short and to the point. 20.88. In the year 2012, what is the difference between the Balance of Payment (as % of service exports) of Hungary and Balance of Payment (as % of service exports) of Ukraine?
Ensure brevity in your answer.  2.57. In the year 2012, what is the difference between the Balance of Payment (as % of service exports) of Hungary and Balance of Payment (as % of service exports) of Vanuatu?
Keep it short and to the point. -56.73. In the year 2012, what is the difference between the Balance of Payment (as % of service exports) of Ireland and Balance of Payment (as % of service exports) of Ukraine?
Your answer should be very brief. -18.31. In the year 2012, what is the difference between the Balance of Payment (as % of service exports) of Ireland and Balance of Payment (as % of service exports) of Vanuatu?
Ensure brevity in your answer.  -77.62. In the year 2012, what is the difference between the Balance of Payment (as % of service exports) of Ukraine and Balance of Payment (as % of service exports) of Vanuatu?
Provide a short and direct response. -59.31. What is the ratio of the Balance of Payment (as % of service exports) of Hungary in 2005 to that in 2006?
Provide a succinct answer. 1.04. What is the ratio of the Balance of Payment (as % of service exports) of Ireland in 2005 to that in 2006?
Make the answer very short. 1.05. What is the ratio of the Balance of Payment (as % of service exports) of Ukraine in 2005 to that in 2006?
Your response must be concise. 1.05. What is the ratio of the Balance of Payment (as % of service exports) of Vanuatu in 2005 to that in 2006?
Ensure brevity in your answer.  0.97. What is the ratio of the Balance of Payment (as % of service exports) in Hungary in 2005 to that in 2007?
Keep it short and to the point. 1.17. What is the ratio of the Balance of Payment (as % of service exports) in Ireland in 2005 to that in 2007?
Provide a succinct answer. 1.16. What is the ratio of the Balance of Payment (as % of service exports) of Hungary in 2005 to that in 2008?
Keep it short and to the point. 1.04. What is the ratio of the Balance of Payment (as % of service exports) in Ireland in 2005 to that in 2008?
Give a very brief answer. 1.22. What is the ratio of the Balance of Payment (as % of service exports) in Vanuatu in 2005 to that in 2008?
Your answer should be very brief. 0.85. What is the ratio of the Balance of Payment (as % of service exports) of Hungary in 2005 to that in 2009?
Ensure brevity in your answer.  1.01. What is the ratio of the Balance of Payment (as % of service exports) in Ireland in 2005 to that in 2009?
Offer a terse response. 1.47. What is the ratio of the Balance of Payment (as % of service exports) of Ukraine in 2005 to that in 2009?
Make the answer very short. 1.25. What is the ratio of the Balance of Payment (as % of service exports) in Vanuatu in 2005 to that in 2009?
Offer a very short reply. 0.8. What is the ratio of the Balance of Payment (as % of service exports) in Hungary in 2005 to that in 2010?
Offer a terse response. 1.13. What is the ratio of the Balance of Payment (as % of service exports) in Ireland in 2005 to that in 2010?
Your answer should be very brief. 1.9. What is the ratio of the Balance of Payment (as % of service exports) in Ukraine in 2005 to that in 2010?
Offer a terse response. 1.45. What is the ratio of the Balance of Payment (as % of service exports) of Vanuatu in 2005 to that in 2010?
Provide a succinct answer. 0.78. What is the ratio of the Balance of Payment (as % of service exports) in Hungary in 2005 to that in 2011?
Your response must be concise. 1.23. What is the ratio of the Balance of Payment (as % of service exports) in Ireland in 2005 to that in 2011?
Ensure brevity in your answer.  2.15. What is the ratio of the Balance of Payment (as % of service exports) in Ukraine in 2005 to that in 2011?
Make the answer very short. 1.48. What is the ratio of the Balance of Payment (as % of service exports) in Vanuatu in 2005 to that in 2011?
Provide a succinct answer. 0.78. What is the ratio of the Balance of Payment (as % of service exports) of Hungary in 2005 to that in 2012?
Offer a terse response. 1.33. What is the ratio of the Balance of Payment (as % of service exports) in Ireland in 2005 to that in 2012?
Offer a very short reply. 2.41. What is the ratio of the Balance of Payment (as % of service exports) in Ukraine in 2005 to that in 2012?
Ensure brevity in your answer.  1.37. What is the ratio of the Balance of Payment (as % of service exports) of Vanuatu in 2005 to that in 2012?
Keep it short and to the point. 0.76. What is the ratio of the Balance of Payment (as % of service exports) of Hungary in 2006 to that in 2007?
Provide a succinct answer. 1.13. What is the ratio of the Balance of Payment (as % of service exports) in Ireland in 2006 to that in 2007?
Your answer should be very brief. 1.1. What is the ratio of the Balance of Payment (as % of service exports) in Ukraine in 2006 to that in 2007?
Ensure brevity in your answer.  0.95. What is the ratio of the Balance of Payment (as % of service exports) in Ireland in 2006 to that in 2008?
Make the answer very short. 1.16. What is the ratio of the Balance of Payment (as % of service exports) in Ukraine in 2006 to that in 2008?
Give a very brief answer. 0.96. What is the ratio of the Balance of Payment (as % of service exports) in Vanuatu in 2006 to that in 2008?
Make the answer very short. 0.88. What is the ratio of the Balance of Payment (as % of service exports) in Hungary in 2006 to that in 2009?
Keep it short and to the point. 0.97. What is the ratio of the Balance of Payment (as % of service exports) of Ireland in 2006 to that in 2009?
Provide a succinct answer. 1.4. What is the ratio of the Balance of Payment (as % of service exports) of Ukraine in 2006 to that in 2009?
Ensure brevity in your answer.  1.2. What is the ratio of the Balance of Payment (as % of service exports) of Vanuatu in 2006 to that in 2009?
Offer a terse response. 0.83. What is the ratio of the Balance of Payment (as % of service exports) in Hungary in 2006 to that in 2010?
Your response must be concise. 1.09. What is the ratio of the Balance of Payment (as % of service exports) in Ireland in 2006 to that in 2010?
Offer a terse response. 1.8. What is the ratio of the Balance of Payment (as % of service exports) of Ukraine in 2006 to that in 2010?
Provide a short and direct response. 1.38. What is the ratio of the Balance of Payment (as % of service exports) of Vanuatu in 2006 to that in 2010?
Offer a terse response. 0.81. What is the ratio of the Balance of Payment (as % of service exports) of Hungary in 2006 to that in 2011?
Offer a terse response. 1.18. What is the ratio of the Balance of Payment (as % of service exports) in Ireland in 2006 to that in 2011?
Your answer should be compact. 2.04. What is the ratio of the Balance of Payment (as % of service exports) in Ukraine in 2006 to that in 2011?
Offer a terse response. 1.42. What is the ratio of the Balance of Payment (as % of service exports) of Vanuatu in 2006 to that in 2011?
Offer a very short reply. 0.8. What is the ratio of the Balance of Payment (as % of service exports) in Hungary in 2006 to that in 2012?
Your response must be concise. 1.28. What is the ratio of the Balance of Payment (as % of service exports) in Ireland in 2006 to that in 2012?
Provide a short and direct response. 2.28. What is the ratio of the Balance of Payment (as % of service exports) in Ukraine in 2006 to that in 2012?
Offer a terse response. 1.31. What is the ratio of the Balance of Payment (as % of service exports) of Vanuatu in 2006 to that in 2012?
Provide a succinct answer. 0.78. What is the ratio of the Balance of Payment (as % of service exports) in Hungary in 2007 to that in 2008?
Provide a succinct answer. 0.88. What is the ratio of the Balance of Payment (as % of service exports) of Ireland in 2007 to that in 2008?
Offer a very short reply. 1.05. What is the ratio of the Balance of Payment (as % of service exports) in Ukraine in 2007 to that in 2008?
Provide a short and direct response. 1.01. What is the ratio of the Balance of Payment (as % of service exports) of Vanuatu in 2007 to that in 2008?
Offer a very short reply. 0.88. What is the ratio of the Balance of Payment (as % of service exports) in Hungary in 2007 to that in 2009?
Provide a short and direct response. 0.86. What is the ratio of the Balance of Payment (as % of service exports) of Ireland in 2007 to that in 2009?
Provide a succinct answer. 1.27. What is the ratio of the Balance of Payment (as % of service exports) in Ukraine in 2007 to that in 2009?
Offer a very short reply. 1.26. What is the ratio of the Balance of Payment (as % of service exports) in Vanuatu in 2007 to that in 2009?
Provide a succinct answer. 0.83. What is the ratio of the Balance of Payment (as % of service exports) of Hungary in 2007 to that in 2010?
Give a very brief answer. 0.96. What is the ratio of the Balance of Payment (as % of service exports) in Ireland in 2007 to that in 2010?
Your response must be concise. 1.63. What is the ratio of the Balance of Payment (as % of service exports) in Ukraine in 2007 to that in 2010?
Ensure brevity in your answer.  1.46. What is the ratio of the Balance of Payment (as % of service exports) of Vanuatu in 2007 to that in 2010?
Ensure brevity in your answer.  0.81. What is the ratio of the Balance of Payment (as % of service exports) of Hungary in 2007 to that in 2011?
Your answer should be compact. 1.05. What is the ratio of the Balance of Payment (as % of service exports) of Ireland in 2007 to that in 2011?
Make the answer very short. 1.85. What is the ratio of the Balance of Payment (as % of service exports) of Ukraine in 2007 to that in 2011?
Your answer should be very brief. 1.49. What is the ratio of the Balance of Payment (as % of service exports) of Vanuatu in 2007 to that in 2011?
Provide a short and direct response. 0.81. What is the ratio of the Balance of Payment (as % of service exports) in Hungary in 2007 to that in 2012?
Provide a short and direct response. 1.13. What is the ratio of the Balance of Payment (as % of service exports) of Ireland in 2007 to that in 2012?
Offer a terse response. 2.07. What is the ratio of the Balance of Payment (as % of service exports) of Ukraine in 2007 to that in 2012?
Ensure brevity in your answer.  1.38. What is the ratio of the Balance of Payment (as % of service exports) in Vanuatu in 2007 to that in 2012?
Provide a short and direct response. 0.79. What is the ratio of the Balance of Payment (as % of service exports) of Hungary in 2008 to that in 2009?
Your answer should be very brief. 0.98. What is the ratio of the Balance of Payment (as % of service exports) in Ireland in 2008 to that in 2009?
Make the answer very short. 1.21. What is the ratio of the Balance of Payment (as % of service exports) in Ukraine in 2008 to that in 2009?
Your answer should be very brief. 1.25. What is the ratio of the Balance of Payment (as % of service exports) in Vanuatu in 2008 to that in 2009?
Keep it short and to the point. 0.94. What is the ratio of the Balance of Payment (as % of service exports) in Hungary in 2008 to that in 2010?
Offer a terse response. 1.09. What is the ratio of the Balance of Payment (as % of service exports) in Ireland in 2008 to that in 2010?
Provide a succinct answer. 1.56. What is the ratio of the Balance of Payment (as % of service exports) of Ukraine in 2008 to that in 2010?
Keep it short and to the point. 1.45. What is the ratio of the Balance of Payment (as % of service exports) in Vanuatu in 2008 to that in 2010?
Offer a terse response. 0.92. What is the ratio of the Balance of Payment (as % of service exports) in Hungary in 2008 to that in 2011?
Provide a short and direct response. 1.18. What is the ratio of the Balance of Payment (as % of service exports) in Ireland in 2008 to that in 2011?
Your answer should be very brief. 1.76. What is the ratio of the Balance of Payment (as % of service exports) of Ukraine in 2008 to that in 2011?
Your response must be concise. 1.48. What is the ratio of the Balance of Payment (as % of service exports) in Hungary in 2008 to that in 2012?
Offer a very short reply. 1.28. What is the ratio of the Balance of Payment (as % of service exports) of Ireland in 2008 to that in 2012?
Give a very brief answer. 1.98. What is the ratio of the Balance of Payment (as % of service exports) in Ukraine in 2008 to that in 2012?
Ensure brevity in your answer.  1.36. What is the ratio of the Balance of Payment (as % of service exports) of Vanuatu in 2008 to that in 2012?
Your answer should be compact. 0.89. What is the ratio of the Balance of Payment (as % of service exports) in Hungary in 2009 to that in 2010?
Make the answer very short. 1.12. What is the ratio of the Balance of Payment (as % of service exports) in Ireland in 2009 to that in 2010?
Make the answer very short. 1.29. What is the ratio of the Balance of Payment (as % of service exports) of Ukraine in 2009 to that in 2010?
Your answer should be compact. 1.16. What is the ratio of the Balance of Payment (as % of service exports) of Vanuatu in 2009 to that in 2010?
Your answer should be very brief. 0.98. What is the ratio of the Balance of Payment (as % of service exports) in Hungary in 2009 to that in 2011?
Your response must be concise. 1.21. What is the ratio of the Balance of Payment (as % of service exports) of Ireland in 2009 to that in 2011?
Make the answer very short. 1.46. What is the ratio of the Balance of Payment (as % of service exports) in Ukraine in 2009 to that in 2011?
Keep it short and to the point. 1.19. What is the ratio of the Balance of Payment (as % of service exports) of Vanuatu in 2009 to that in 2011?
Your response must be concise. 0.97. What is the ratio of the Balance of Payment (as % of service exports) in Hungary in 2009 to that in 2012?
Make the answer very short. 1.31. What is the ratio of the Balance of Payment (as % of service exports) of Ireland in 2009 to that in 2012?
Ensure brevity in your answer.  1.64. What is the ratio of the Balance of Payment (as % of service exports) in Ukraine in 2009 to that in 2012?
Make the answer very short. 1.09. What is the ratio of the Balance of Payment (as % of service exports) of Vanuatu in 2009 to that in 2012?
Ensure brevity in your answer.  0.94. What is the ratio of the Balance of Payment (as % of service exports) of Hungary in 2010 to that in 2011?
Your response must be concise. 1.09. What is the ratio of the Balance of Payment (as % of service exports) in Ireland in 2010 to that in 2011?
Offer a very short reply. 1.13. What is the ratio of the Balance of Payment (as % of service exports) in Ukraine in 2010 to that in 2011?
Your answer should be compact. 1.02. What is the ratio of the Balance of Payment (as % of service exports) of Hungary in 2010 to that in 2012?
Keep it short and to the point. 1.18. What is the ratio of the Balance of Payment (as % of service exports) in Ireland in 2010 to that in 2012?
Provide a succinct answer. 1.27. What is the ratio of the Balance of Payment (as % of service exports) in Ukraine in 2010 to that in 2012?
Keep it short and to the point. 0.94. What is the ratio of the Balance of Payment (as % of service exports) in Vanuatu in 2010 to that in 2012?
Offer a terse response. 0.97. What is the ratio of the Balance of Payment (as % of service exports) in Hungary in 2011 to that in 2012?
Ensure brevity in your answer.  1.08. What is the ratio of the Balance of Payment (as % of service exports) of Ireland in 2011 to that in 2012?
Make the answer very short. 1.12. What is the ratio of the Balance of Payment (as % of service exports) in Ukraine in 2011 to that in 2012?
Offer a very short reply. 0.92. What is the ratio of the Balance of Payment (as % of service exports) of Vanuatu in 2011 to that in 2012?
Provide a succinct answer. 0.97. What is the difference between the highest and the second highest Balance of Payment (as % of service exports) of Hungary?
Offer a very short reply. 0.39. What is the difference between the highest and the second highest Balance of Payment (as % of service exports) in Ireland?
Keep it short and to the point. 0.45. What is the difference between the highest and the second highest Balance of Payment (as % of service exports) in Ukraine?
Your answer should be very brief. 0.23. What is the difference between the highest and the second highest Balance of Payment (as % of service exports) of Vanuatu?
Your response must be concise. 2.23. What is the difference between the highest and the lowest Balance of Payment (as % of service exports) of Hungary?
Make the answer very short. 8.09. What is the difference between the highest and the lowest Balance of Payment (as % of service exports) in Ireland?
Your answer should be very brief. 5.09. What is the difference between the highest and the lowest Balance of Payment (as % of service exports) in Ukraine?
Your answer should be very brief. 9.97. What is the difference between the highest and the lowest Balance of Payment (as % of service exports) in Vanuatu?
Give a very brief answer. 19.67. 